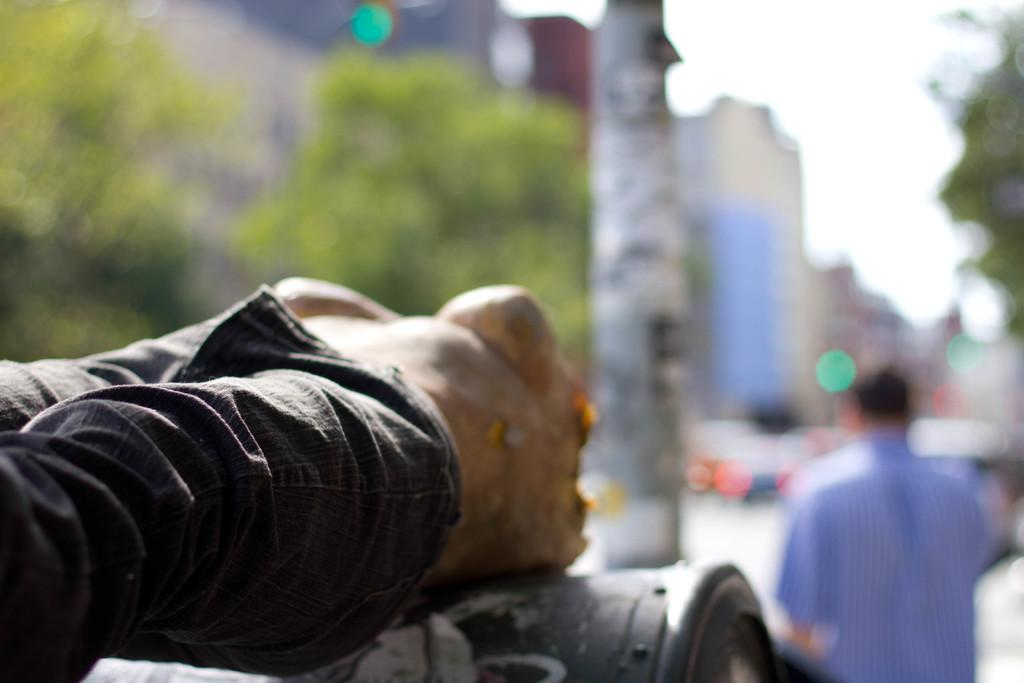What is located on the left side of the image? There is cloth on the left side of the image. What can be seen in the background of the image? Trees, buildings, windows, vehicles on the road, and the sky are visible in the background of the image. Can you describe the person in the background of the image? There is a person in the background of the image, but no specific details about the person are provided. What industry is causing the pollution visible in the image? There is no visible pollution in the image, and therefore no industry causing it. 